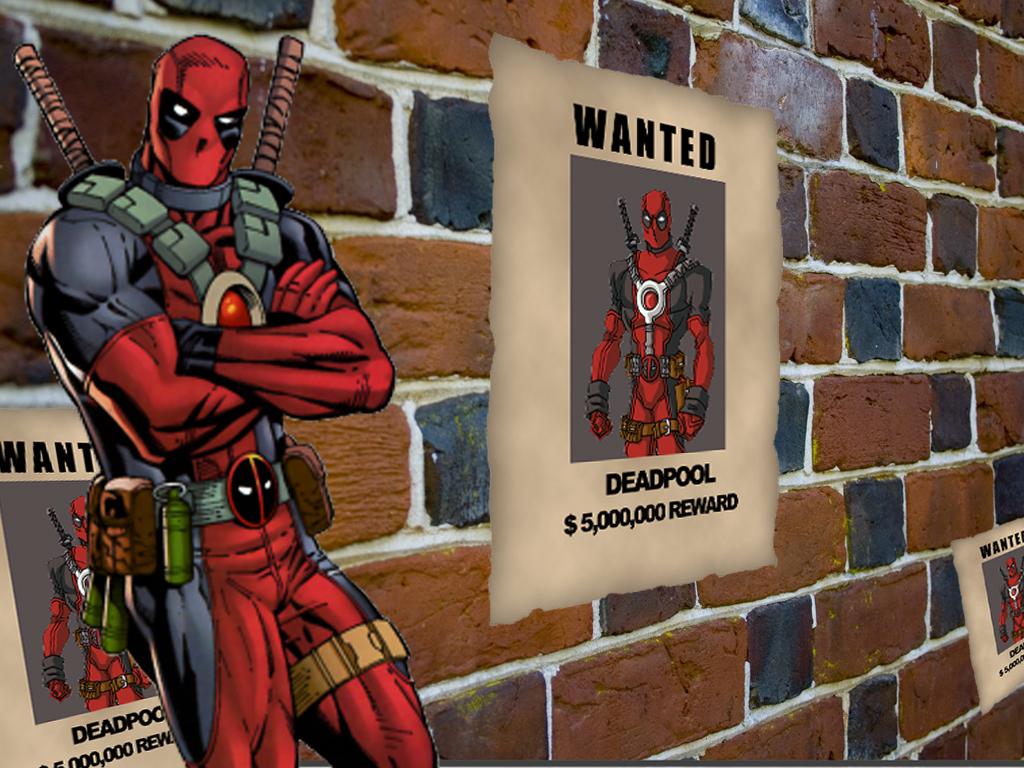How much is the reward?
Make the answer very short. $5,000,000. What is the word at the top?
Your answer should be compact. Wanted. 